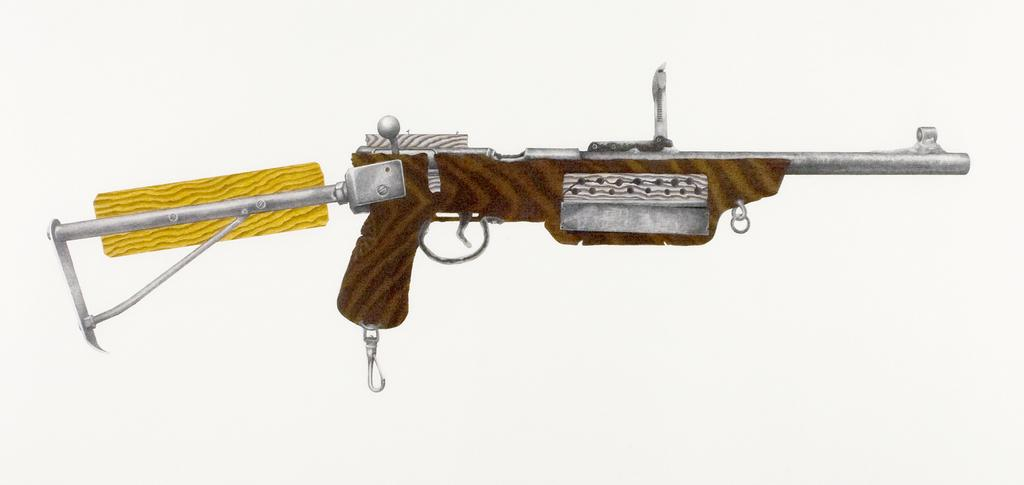What is the main subject of the image? The main subject of the image is a picture of a gun. What type of mint is growing near the gun in the image? There is no mint present in the image; it only features a picture of a gun. 